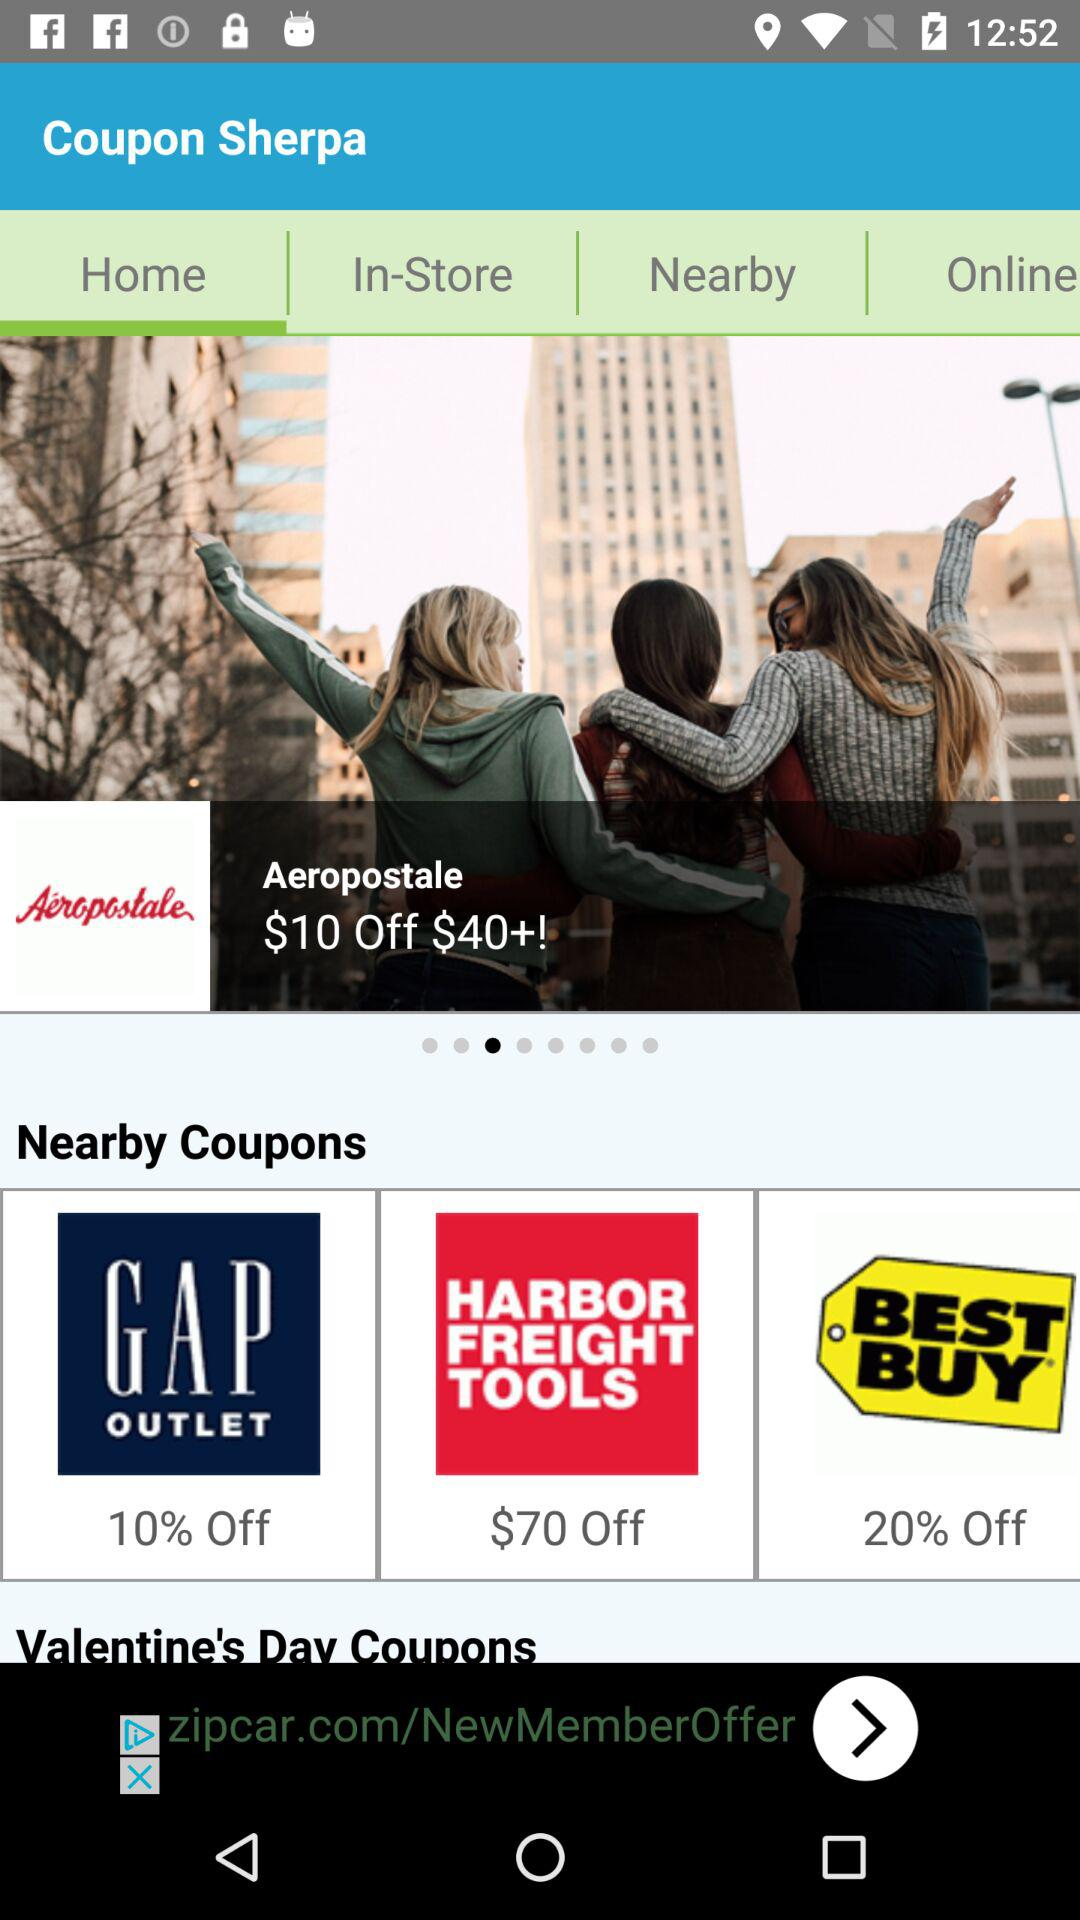How much is off on "HARBOR FREIGHT TOOLS"? There is $70 off on "HARBOR FREIGHT TOOLS". 